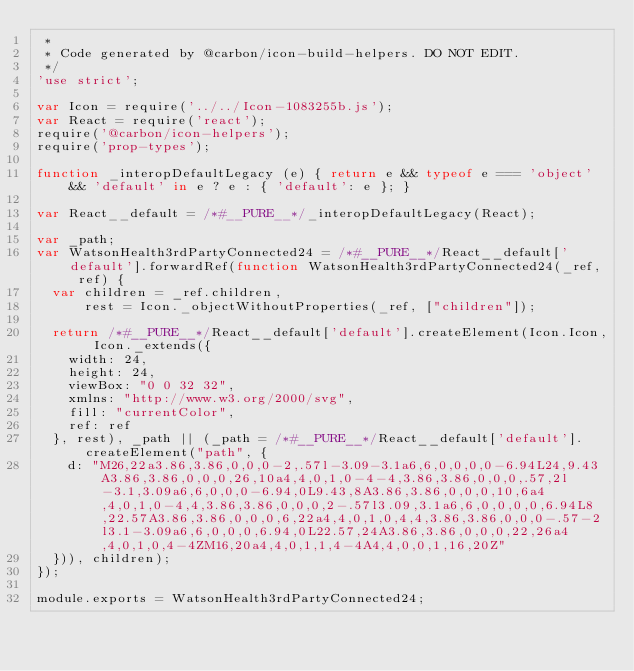<code> <loc_0><loc_0><loc_500><loc_500><_JavaScript_> *
 * Code generated by @carbon/icon-build-helpers. DO NOT EDIT.
 */
'use strict';

var Icon = require('../../Icon-1083255b.js');
var React = require('react');
require('@carbon/icon-helpers');
require('prop-types');

function _interopDefaultLegacy (e) { return e && typeof e === 'object' && 'default' in e ? e : { 'default': e }; }

var React__default = /*#__PURE__*/_interopDefaultLegacy(React);

var _path;
var WatsonHealth3rdPartyConnected24 = /*#__PURE__*/React__default['default'].forwardRef(function WatsonHealth3rdPartyConnected24(_ref, ref) {
  var children = _ref.children,
      rest = Icon._objectWithoutProperties(_ref, ["children"]);

  return /*#__PURE__*/React__default['default'].createElement(Icon.Icon, Icon._extends({
    width: 24,
    height: 24,
    viewBox: "0 0 32 32",
    xmlns: "http://www.w3.org/2000/svg",
    fill: "currentColor",
    ref: ref
  }, rest), _path || (_path = /*#__PURE__*/React__default['default'].createElement("path", {
    d: "M26,22a3.86,3.86,0,0,0-2,.57l-3.09-3.1a6,6,0,0,0,0-6.94L24,9.43A3.86,3.86,0,0,0,26,10a4,4,0,1,0-4-4,3.86,3.86,0,0,0,.57,2l-3.1,3.09a6,6,0,0,0-6.94,0L9.43,8A3.86,3.86,0,0,0,10,6a4,4,0,1,0-4,4,3.86,3.86,0,0,0,2-.57l3.09,3.1a6,6,0,0,0,0,6.94L8,22.57A3.86,3.86,0,0,0,6,22a4,4,0,1,0,4,4,3.86,3.86,0,0,0-.57-2l3.1-3.09a6,6,0,0,0,6.94,0L22.57,24A3.86,3.86,0,0,0,22,26a4,4,0,1,0,4-4ZM16,20a4,4,0,1,1,4-4A4,4,0,0,1,16,20Z"
  })), children);
});

module.exports = WatsonHealth3rdPartyConnected24;
</code> 